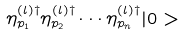Convert formula to latex. <formula><loc_0><loc_0><loc_500><loc_500>\eta ^ { ( l ) \dagger } _ { p _ { 1 } } \eta ^ { ( l ) \dagger } _ { p _ { 2 } } \cdots \eta ^ { ( l ) \dagger } _ { p _ { n } } | 0 ></formula> 